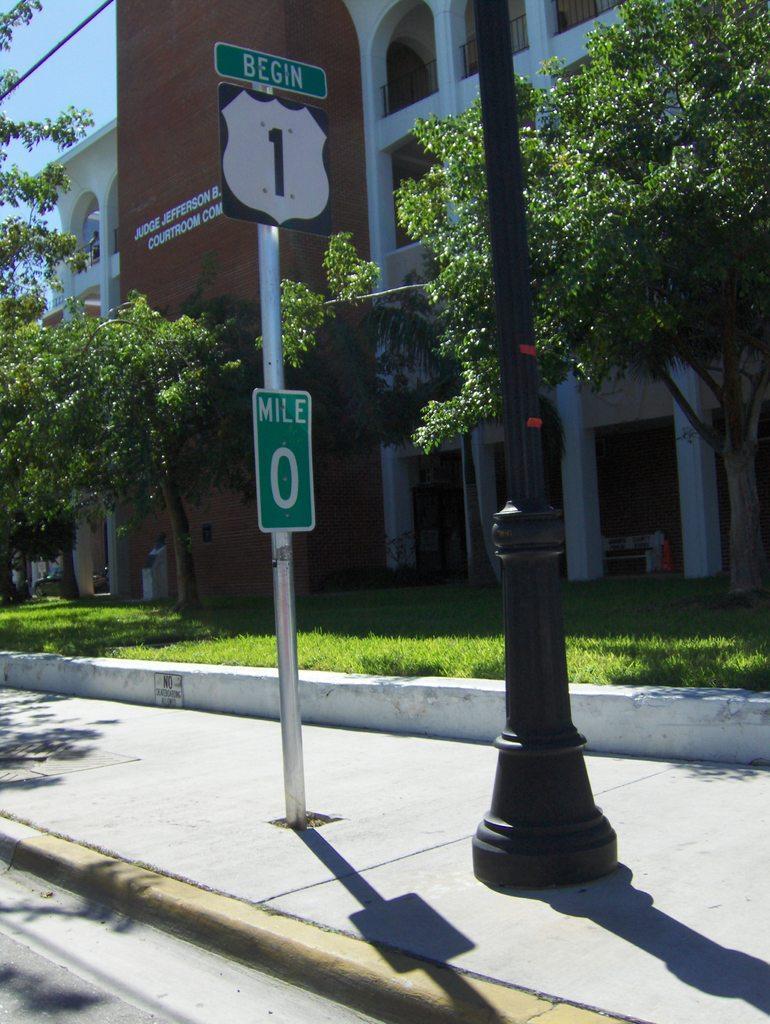Please provide a concise description of this image. In this picture I can observe a pole in the middle of the picture. There is a building in the background. I can observe some trees and grass on the ground. On the right side I can observe black color pole. 